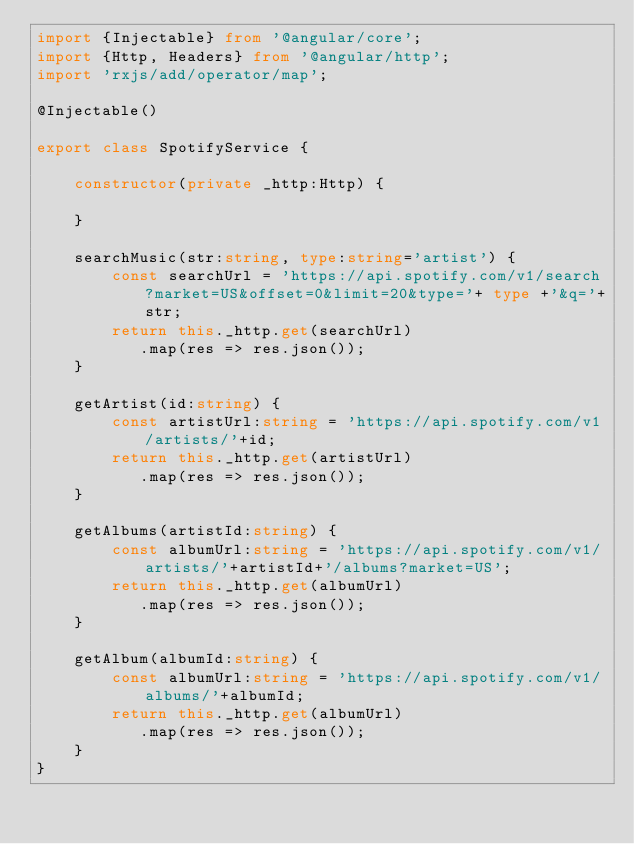Convert code to text. <code><loc_0><loc_0><loc_500><loc_500><_TypeScript_>import {Injectable} from '@angular/core';
import {Http, Headers} from '@angular/http';
import 'rxjs/add/operator/map';

@Injectable()

export class SpotifyService {

	constructor(private _http:Http) {

	}

	searchMusic(str:string, type:string='artist') {
		const searchUrl = 'https://api.spotify.com/v1/search?market=US&offset=0&limit=20&type='+ type +'&q='+str;
		return this._http.get(searchUrl)
		   .map(res => res.json());		
	}

	getArtist(id:string) {
		const artistUrl:string = 'https://api.spotify.com/v1/artists/'+id;
		return this._http.get(artistUrl)
		   .map(res => res.json());		
	}

	getAlbums(artistId:string) {
		const albumUrl:string = 'https://api.spotify.com/v1/artists/'+artistId+'/albums?market=US';
		return this._http.get(albumUrl)
		   .map(res => res.json());
	}

	getAlbum(albumId:string) {
		const albumUrl:string = 'https://api.spotify.com/v1/albums/'+albumId;
		return this._http.get(albumUrl)
		   .map(res => res.json());
	}
}
</code> 